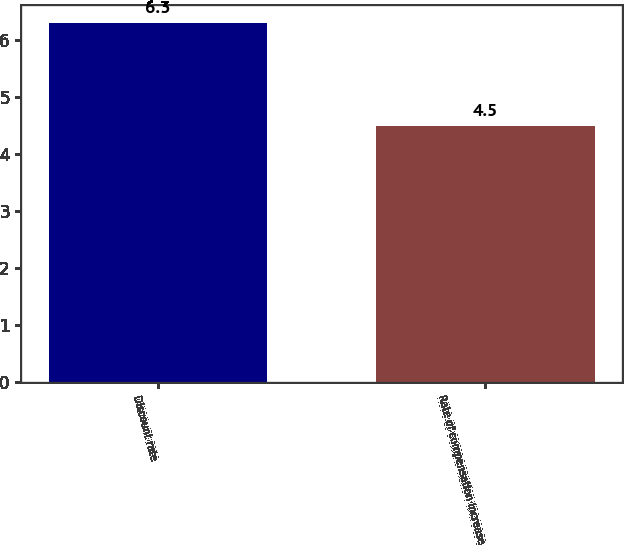<chart> <loc_0><loc_0><loc_500><loc_500><bar_chart><fcel>Discount rate<fcel>Rate of compensation increase<nl><fcel>6.3<fcel>4.5<nl></chart> 